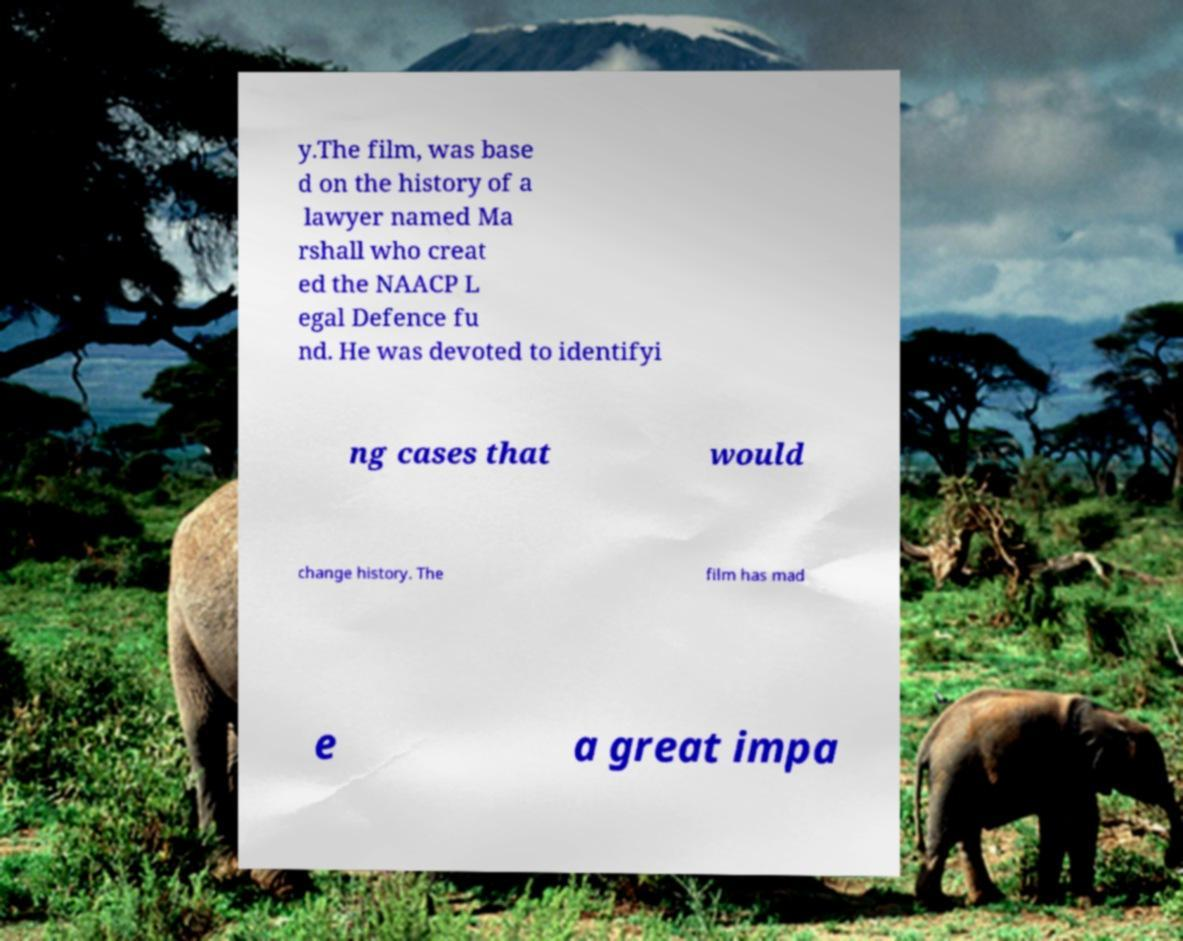I need the written content from this picture converted into text. Can you do that? y.The film, was base d on the history of a lawyer named Ma rshall who creat ed the NAACP L egal Defence fu nd. He was devoted to identifyi ng cases that would change history. The film has mad e a great impa 